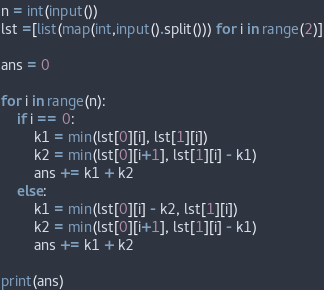<code> <loc_0><loc_0><loc_500><loc_500><_Python_>n = int(input())
lst =[list(map(int,input().split())) for i in range(2)]

ans = 0

for i in range(n):
    if i == 0:
        k1 = min(lst[0][i], lst[1][i])
        k2 = min(lst[0][i+1], lst[1][i] - k1)
        ans += k1 + k2
    else:
        k1 = min(lst[0][i] - k2, lst[1][i])
        k2 = min(lst[0][i+1], lst[1][i] - k1)
        ans += k1 + k2

print(ans)</code> 